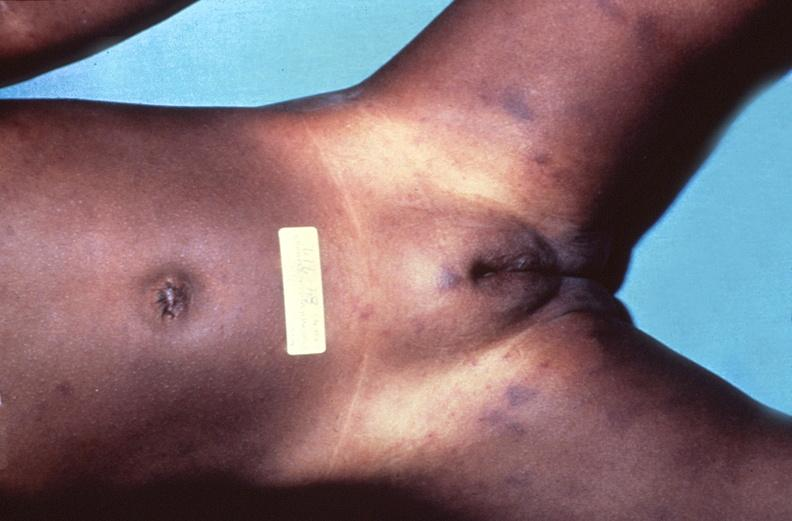what does this image show?
Answer the question using a single word or phrase. Meningococcemia 